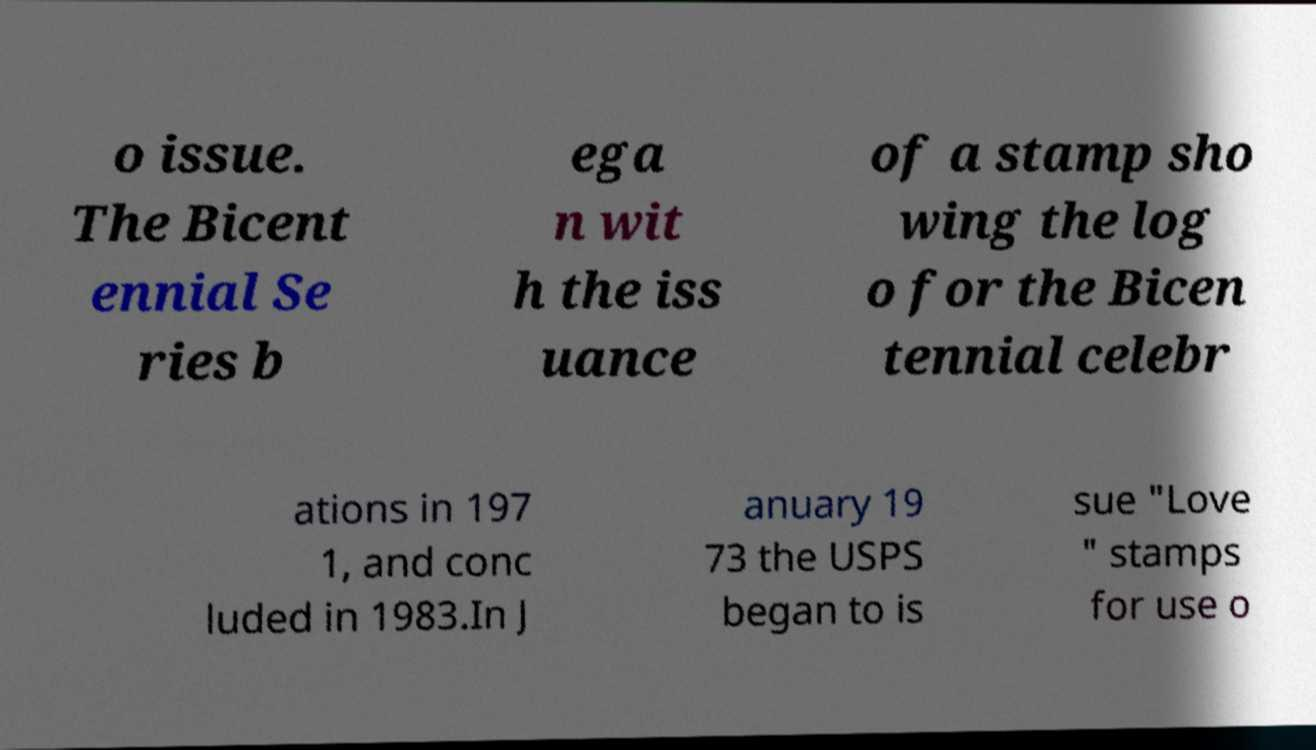Can you accurately transcribe the text from the provided image for me? o issue. The Bicent ennial Se ries b ega n wit h the iss uance of a stamp sho wing the log o for the Bicen tennial celebr ations in 197 1, and conc luded in 1983.In J anuary 19 73 the USPS began to is sue "Love " stamps for use o 